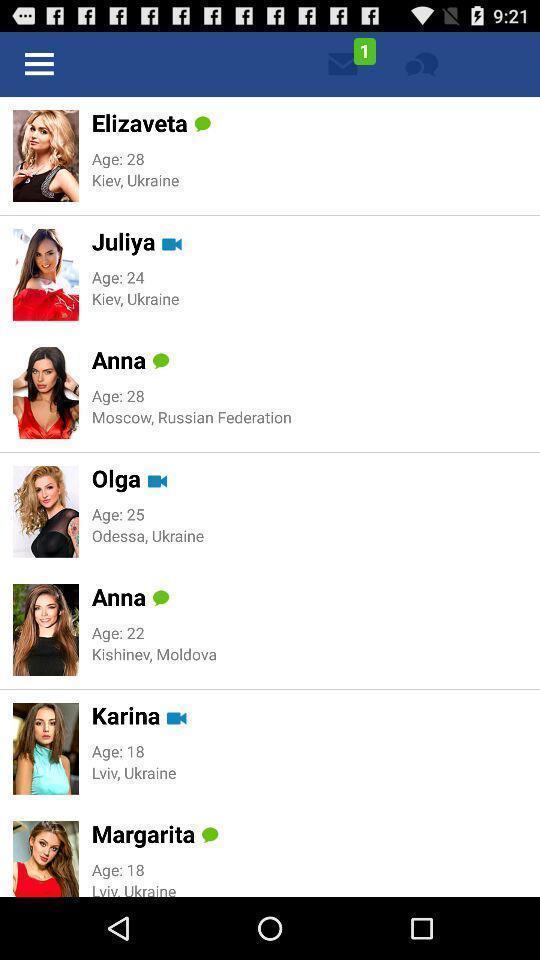Provide a detailed account of this screenshot. Page showing a variety of profiles. 